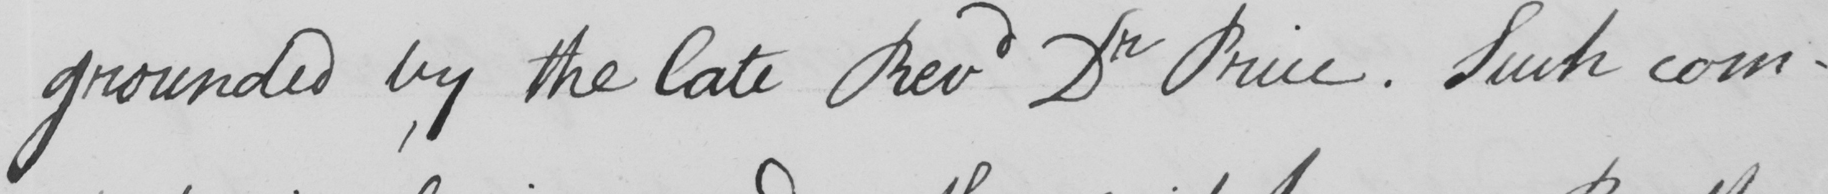Transcribe the text shown in this historical manuscript line. grounded by the late Revd Dr Price . Such com- 